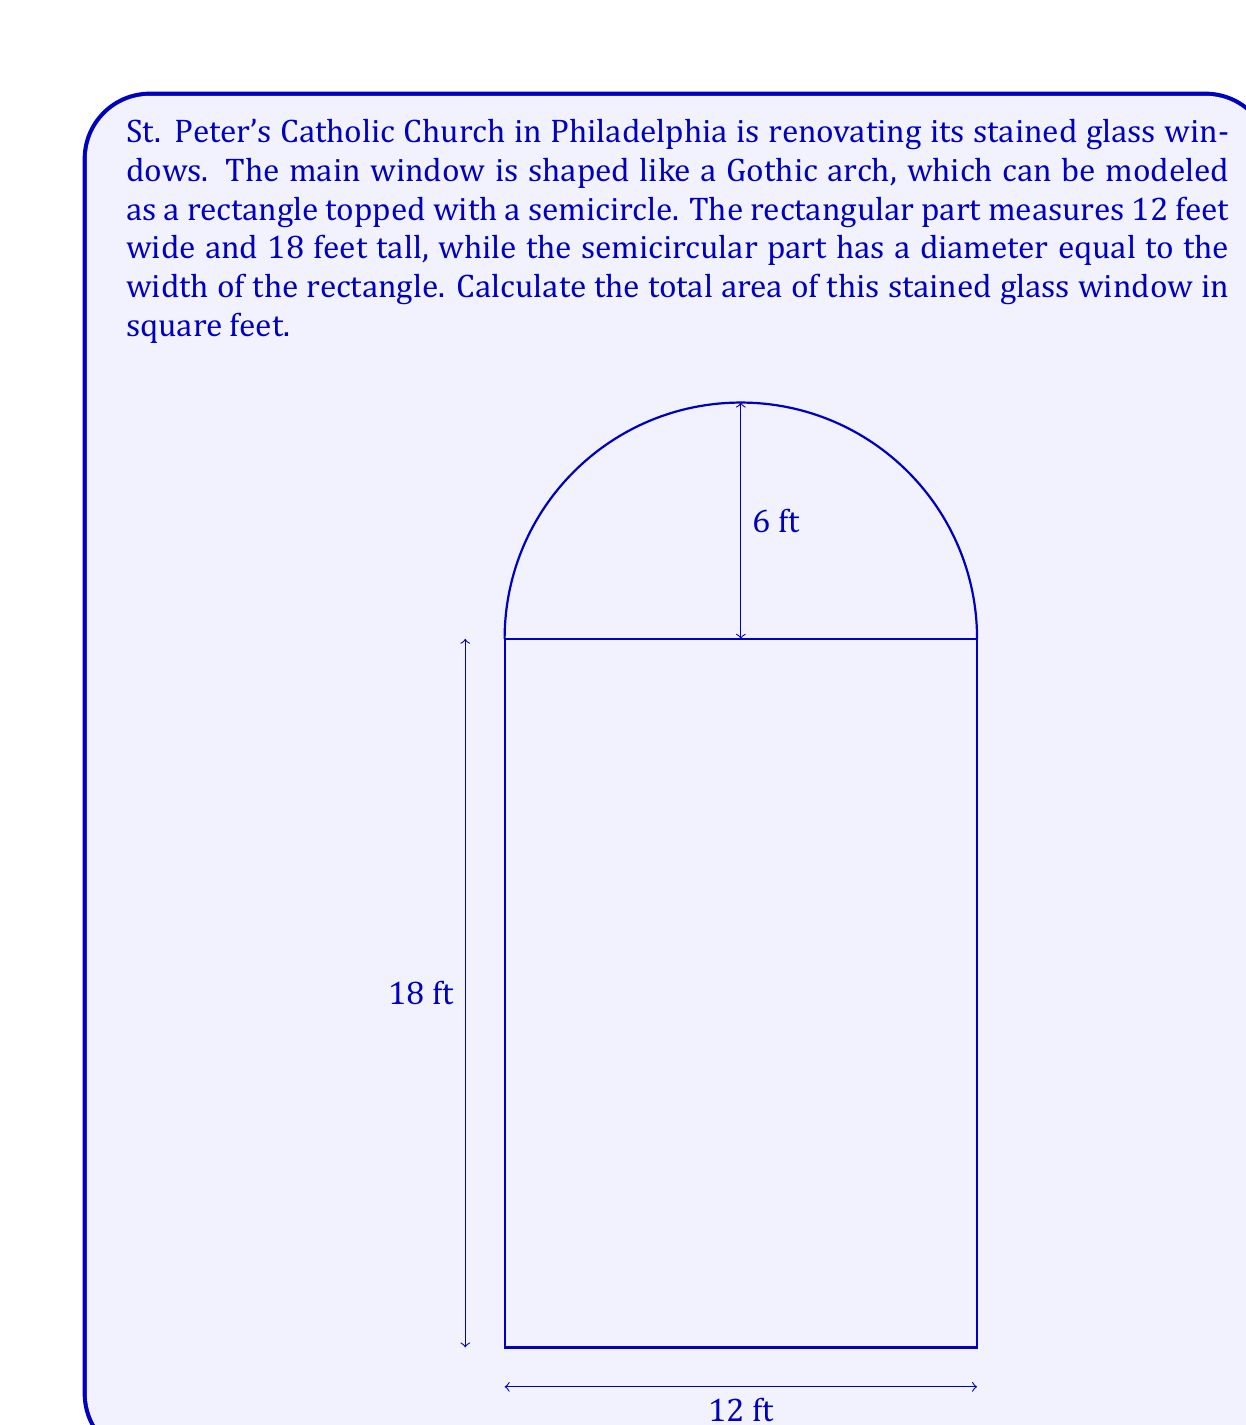Show me your answer to this math problem. To calculate the total area of the stained glass window, we need to find the sum of the areas of the rectangular part and the semicircular part.

1. Area of the rectangle:
   $A_r = w \times h$
   $A_r = 12 \text{ ft} \times 18 \text{ ft} = 216 \text{ sq ft}$

2. Area of the semicircle:
   The diameter of the semicircle is equal to the width of the rectangle, which is 12 ft.
   So, the radius is 6 ft.
   
   Area of a full circle: $A_c = \pi r^2$
   Area of a semicircle: $A_s = \frac{1}{2} \pi r^2$

   $A_s = \frac{1}{2} \times \pi \times 6^2 \text{ sq ft}$
   $A_s = \frac{1}{2} \times \pi \times 36 \text{ sq ft}$
   $A_s = 18\pi \text{ sq ft}$

3. Total area:
   $A_{\text{total}} = A_r + A_s$
   $A_{\text{total}} = 216 + 18\pi \text{ sq ft}$
   $A_{\text{total}} = 216 + 56.55 \text{ sq ft}$ (rounded to 2 decimal places)
   $A_{\text{total}} = 272.55 \text{ sq ft}$
Answer: The total area of the stained glass window is approximately 272.55 square feet. 